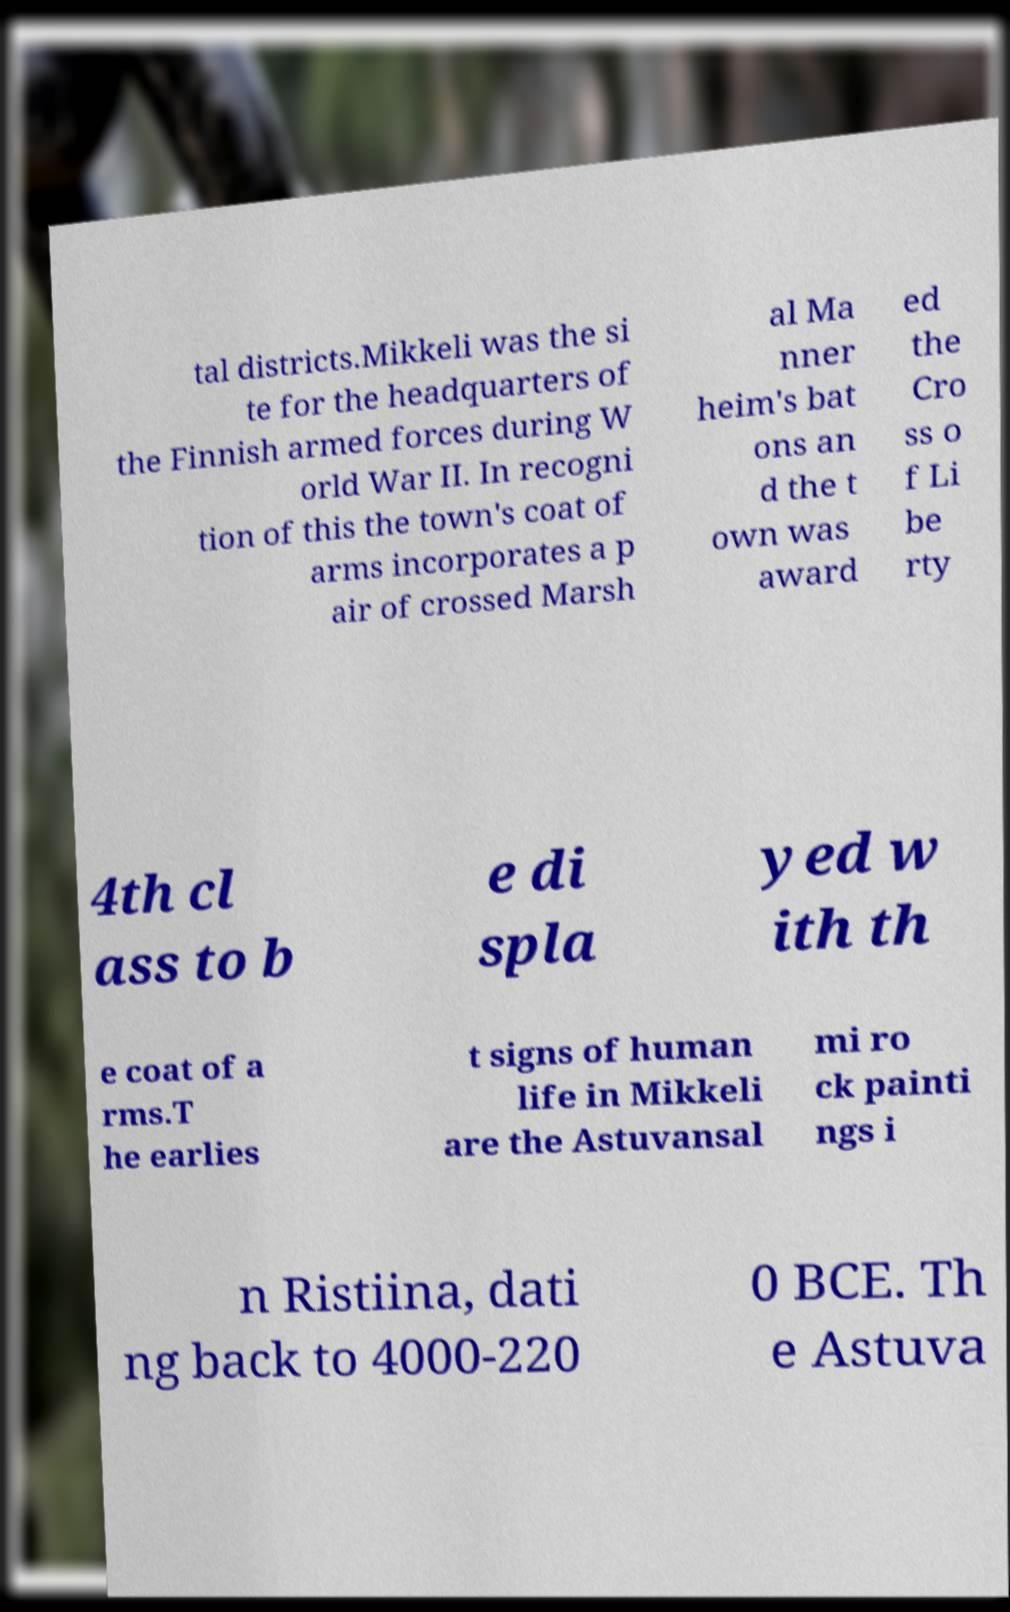Could you assist in decoding the text presented in this image and type it out clearly? tal districts.Mikkeli was the si te for the headquarters of the Finnish armed forces during W orld War II. In recogni tion of this the town's coat of arms incorporates a p air of crossed Marsh al Ma nner heim's bat ons an d the t own was award ed the Cro ss o f Li be rty 4th cl ass to b e di spla yed w ith th e coat of a rms.T he earlies t signs of human life in Mikkeli are the Astuvansal mi ro ck painti ngs i n Ristiina, dati ng back to 4000-220 0 BCE. Th e Astuva 